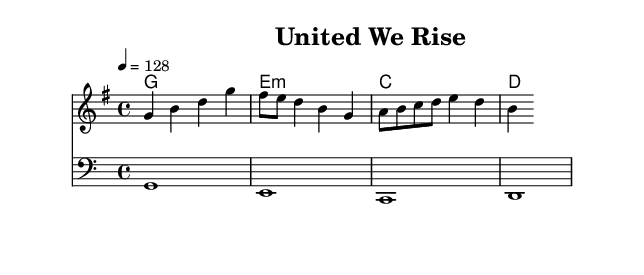What is the key signature of this music? The key signature indicated is G major, which has one sharp (F#). Looking at the clef and the key signature at the beginning of the score, I can confirm that it is G major.
Answer: G major What is the time signature of this music? The time signature shown is 4/4, indicated at the start of the score. It means there are four beats in each measure and a quarter note gets one beat.
Answer: 4/4 What is the tempo marking of this piece? The tempo marking is given as "4 = 128", which means that quarter notes are played at a rate of 128 beats per minute. This is indicated at the top of the score under the global section.
Answer: 128 Which chord is played in the first measure of the harmonies? The first measure of the harmonies shows a G major chord, represented as "g1." This can be identified by the chord names listed that correlate to the notes being played.
Answer: G How many measures are there in the melody? The melody consists of four distinct measures, as indicated by the structure of the notes and the bar lines separating them in the score. Counting the measures gives a total of four.
Answer: 4 Is there a bass part, and if so, what is the first note played? Yes, there is a bass part indicated in the score, and the first note played is G, which is shown in the bass clef in the initial measure of the score.
Answer: G What type of chord progression is used in this piece? The chord progression follows a simple and common pattern: G major to E minor to C major to D major. This is a well-known progression often used in electropop and other genres for creating uplifting and celebratory music.
Answer: G - E minor - C - D 